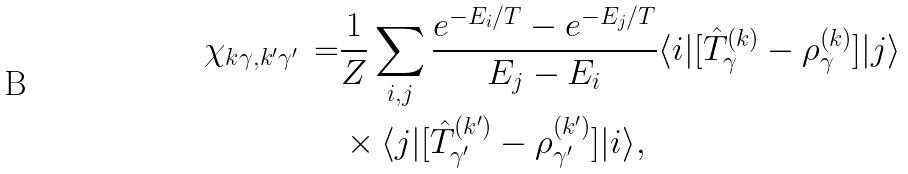<formula> <loc_0><loc_0><loc_500><loc_500>\chi _ { k \gamma , k ^ { \prime } \gamma ^ { \prime } } \, = & \frac { 1 } { Z } \sum _ { i , j } \frac { e ^ { - E _ { i } / T } - e ^ { - E _ { j } / T } } { E _ { j } - E _ { i } } \langle i | [ { \hat { T } } ^ { ( k ) } _ { \gamma } - \rho ^ { ( k ) } _ { \gamma } ] | j \rangle \\ & \times \langle j | [ { \hat { T } } ^ { ( k ^ { \prime } ) } _ { \gamma ^ { \prime } } - \rho ^ { ( k ^ { \prime } ) } _ { \gamma ^ { \prime } } ] | i \rangle ,</formula> 